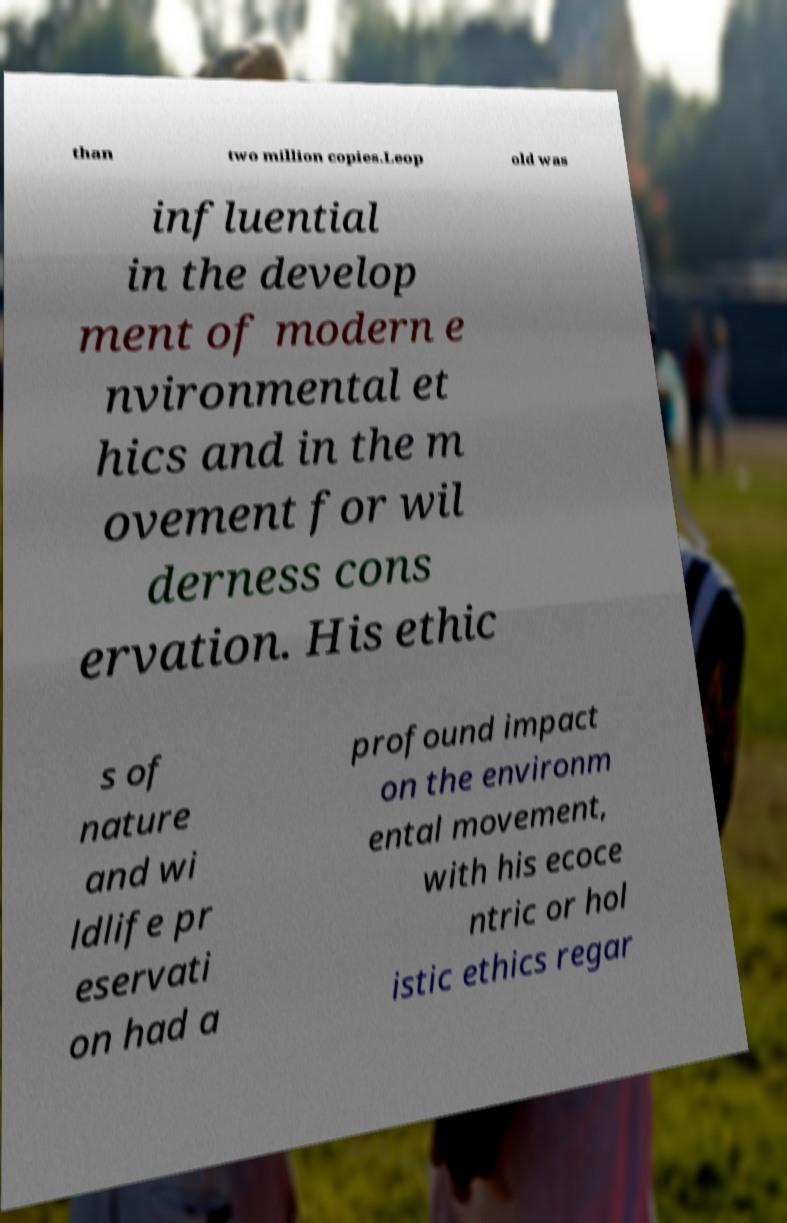Can you read and provide the text displayed in the image?This photo seems to have some interesting text. Can you extract and type it out for me? than two million copies.Leop old was influential in the develop ment of modern e nvironmental et hics and in the m ovement for wil derness cons ervation. His ethic s of nature and wi ldlife pr eservati on had a profound impact on the environm ental movement, with his ecoce ntric or hol istic ethics regar 